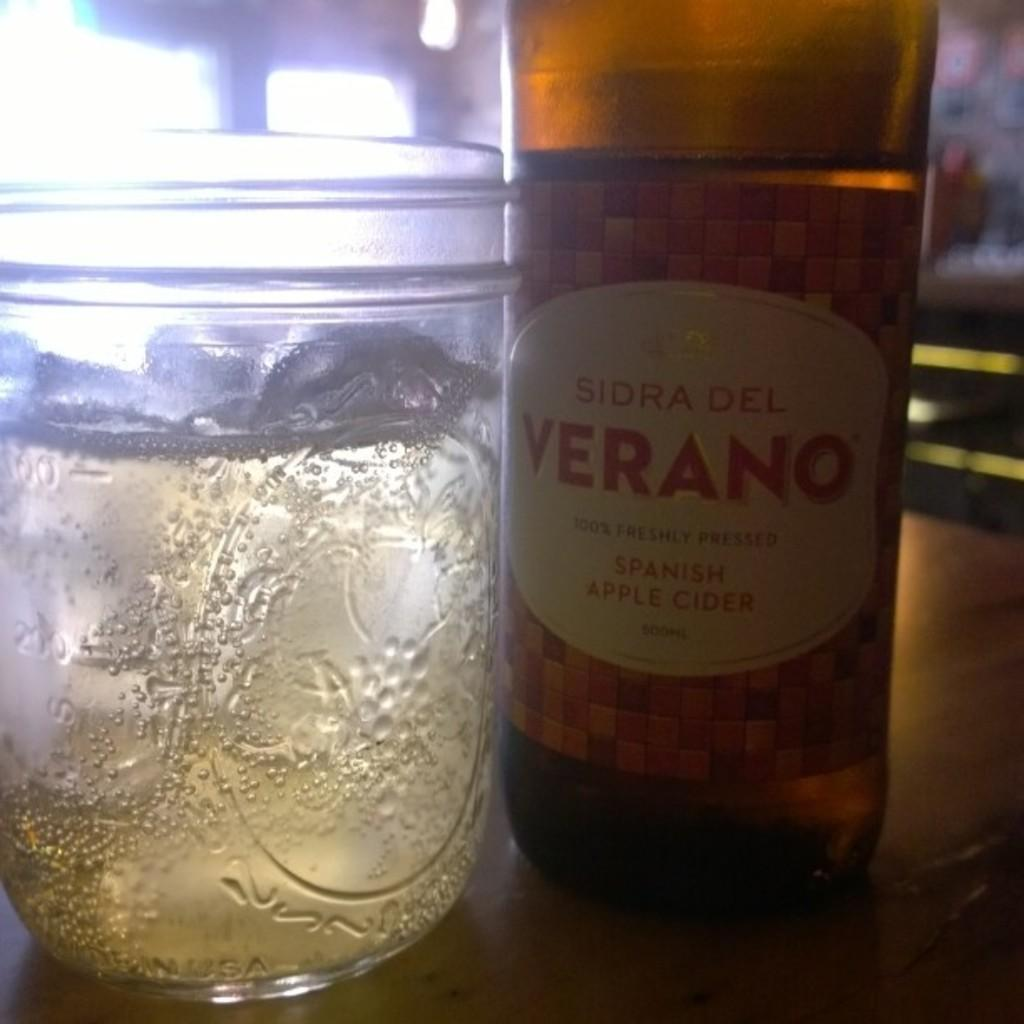<image>
Create a compact narrative representing the image presented. A Sidra del Verano bottle sits next to a glass. 